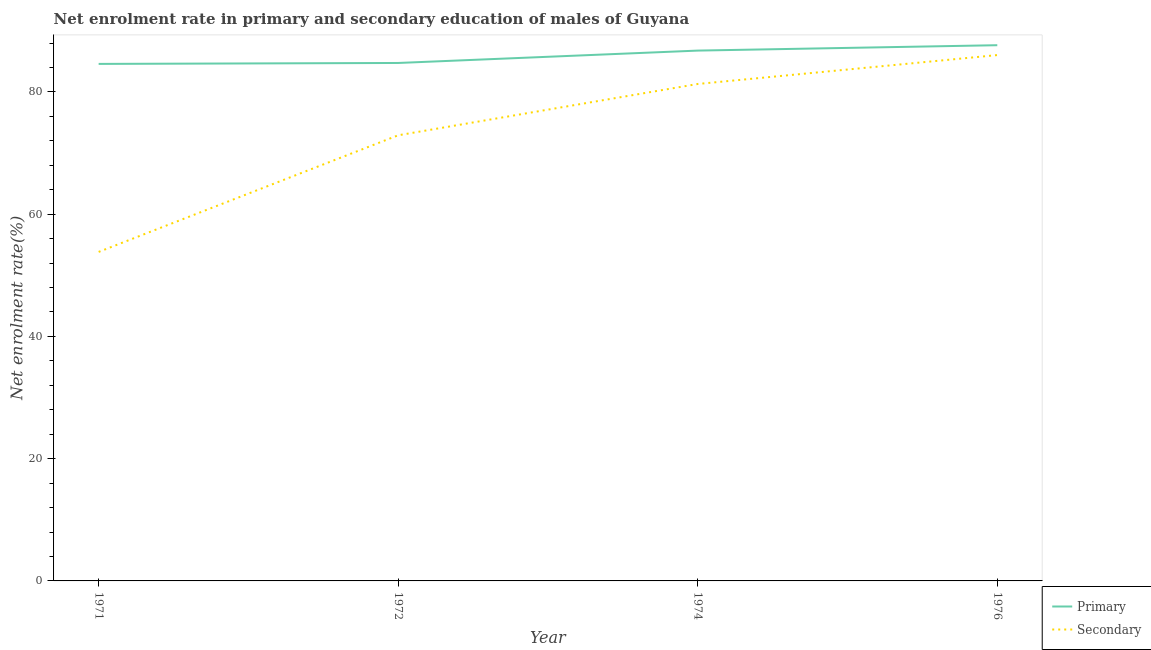How many different coloured lines are there?
Provide a succinct answer. 2. Does the line corresponding to enrollment rate in secondary education intersect with the line corresponding to enrollment rate in primary education?
Keep it short and to the point. No. What is the enrollment rate in primary education in 1971?
Your answer should be compact. 84.59. Across all years, what is the maximum enrollment rate in primary education?
Provide a short and direct response. 87.65. Across all years, what is the minimum enrollment rate in primary education?
Keep it short and to the point. 84.59. In which year was the enrollment rate in secondary education maximum?
Your response must be concise. 1976. What is the total enrollment rate in secondary education in the graph?
Your response must be concise. 294.07. What is the difference between the enrollment rate in secondary education in 1972 and that in 1974?
Offer a terse response. -8.39. What is the difference between the enrollment rate in secondary education in 1974 and the enrollment rate in primary education in 1971?
Your response must be concise. -3.28. What is the average enrollment rate in primary education per year?
Your answer should be compact. 85.93. In the year 1976, what is the difference between the enrollment rate in primary education and enrollment rate in secondary education?
Provide a short and direct response. 1.61. In how many years, is the enrollment rate in secondary education greater than 28 %?
Offer a very short reply. 4. What is the ratio of the enrollment rate in primary education in 1971 to that in 1976?
Provide a short and direct response. 0.97. What is the difference between the highest and the second highest enrollment rate in primary education?
Offer a terse response. 0.88. What is the difference between the highest and the lowest enrollment rate in secondary education?
Offer a very short reply. 32.21. In how many years, is the enrollment rate in primary education greater than the average enrollment rate in primary education taken over all years?
Offer a terse response. 2. Is the sum of the enrollment rate in primary education in 1971 and 1974 greater than the maximum enrollment rate in secondary education across all years?
Make the answer very short. Yes. Does the enrollment rate in primary education monotonically increase over the years?
Make the answer very short. Yes. Is the enrollment rate in secondary education strictly less than the enrollment rate in primary education over the years?
Ensure brevity in your answer.  Yes. How many lines are there?
Give a very brief answer. 2. How many years are there in the graph?
Offer a very short reply. 4. What is the difference between two consecutive major ticks on the Y-axis?
Ensure brevity in your answer.  20. Where does the legend appear in the graph?
Make the answer very short. Bottom right. What is the title of the graph?
Offer a very short reply. Net enrolment rate in primary and secondary education of males of Guyana. What is the label or title of the Y-axis?
Ensure brevity in your answer.  Net enrolment rate(%). What is the Net enrolment rate(%) of Primary in 1971?
Your response must be concise. 84.59. What is the Net enrolment rate(%) of Secondary in 1971?
Provide a succinct answer. 53.83. What is the Net enrolment rate(%) of Primary in 1972?
Provide a short and direct response. 84.74. What is the Net enrolment rate(%) of Secondary in 1972?
Your answer should be very brief. 72.91. What is the Net enrolment rate(%) of Primary in 1974?
Your answer should be compact. 86.76. What is the Net enrolment rate(%) of Secondary in 1974?
Your answer should be compact. 81.3. What is the Net enrolment rate(%) in Primary in 1976?
Provide a succinct answer. 87.65. What is the Net enrolment rate(%) in Secondary in 1976?
Your answer should be compact. 86.03. Across all years, what is the maximum Net enrolment rate(%) in Primary?
Keep it short and to the point. 87.65. Across all years, what is the maximum Net enrolment rate(%) in Secondary?
Make the answer very short. 86.03. Across all years, what is the minimum Net enrolment rate(%) of Primary?
Your response must be concise. 84.59. Across all years, what is the minimum Net enrolment rate(%) in Secondary?
Offer a very short reply. 53.83. What is the total Net enrolment rate(%) of Primary in the graph?
Your answer should be very brief. 343.74. What is the total Net enrolment rate(%) of Secondary in the graph?
Provide a short and direct response. 294.07. What is the difference between the Net enrolment rate(%) of Primary in 1971 and that in 1972?
Your response must be concise. -0.15. What is the difference between the Net enrolment rate(%) in Secondary in 1971 and that in 1972?
Keep it short and to the point. -19.08. What is the difference between the Net enrolment rate(%) in Primary in 1971 and that in 1974?
Your answer should be very brief. -2.18. What is the difference between the Net enrolment rate(%) in Secondary in 1971 and that in 1974?
Make the answer very short. -27.47. What is the difference between the Net enrolment rate(%) of Primary in 1971 and that in 1976?
Your answer should be very brief. -3.06. What is the difference between the Net enrolment rate(%) in Secondary in 1971 and that in 1976?
Your answer should be very brief. -32.21. What is the difference between the Net enrolment rate(%) of Primary in 1972 and that in 1974?
Your response must be concise. -2.02. What is the difference between the Net enrolment rate(%) in Secondary in 1972 and that in 1974?
Keep it short and to the point. -8.39. What is the difference between the Net enrolment rate(%) in Primary in 1972 and that in 1976?
Provide a succinct answer. -2.91. What is the difference between the Net enrolment rate(%) in Secondary in 1972 and that in 1976?
Give a very brief answer. -13.12. What is the difference between the Net enrolment rate(%) in Primary in 1974 and that in 1976?
Your answer should be very brief. -0.88. What is the difference between the Net enrolment rate(%) of Secondary in 1974 and that in 1976?
Your response must be concise. -4.73. What is the difference between the Net enrolment rate(%) in Primary in 1971 and the Net enrolment rate(%) in Secondary in 1972?
Offer a very short reply. 11.68. What is the difference between the Net enrolment rate(%) of Primary in 1971 and the Net enrolment rate(%) of Secondary in 1974?
Keep it short and to the point. 3.28. What is the difference between the Net enrolment rate(%) in Primary in 1971 and the Net enrolment rate(%) in Secondary in 1976?
Offer a very short reply. -1.45. What is the difference between the Net enrolment rate(%) in Primary in 1972 and the Net enrolment rate(%) in Secondary in 1974?
Give a very brief answer. 3.44. What is the difference between the Net enrolment rate(%) of Primary in 1972 and the Net enrolment rate(%) of Secondary in 1976?
Provide a short and direct response. -1.29. What is the difference between the Net enrolment rate(%) in Primary in 1974 and the Net enrolment rate(%) in Secondary in 1976?
Provide a short and direct response. 0.73. What is the average Net enrolment rate(%) of Primary per year?
Your answer should be compact. 85.93. What is the average Net enrolment rate(%) in Secondary per year?
Your answer should be compact. 73.52. In the year 1971, what is the difference between the Net enrolment rate(%) of Primary and Net enrolment rate(%) of Secondary?
Your answer should be compact. 30.76. In the year 1972, what is the difference between the Net enrolment rate(%) of Primary and Net enrolment rate(%) of Secondary?
Your response must be concise. 11.83. In the year 1974, what is the difference between the Net enrolment rate(%) of Primary and Net enrolment rate(%) of Secondary?
Provide a succinct answer. 5.46. In the year 1976, what is the difference between the Net enrolment rate(%) of Primary and Net enrolment rate(%) of Secondary?
Offer a terse response. 1.61. What is the ratio of the Net enrolment rate(%) of Secondary in 1971 to that in 1972?
Provide a short and direct response. 0.74. What is the ratio of the Net enrolment rate(%) of Primary in 1971 to that in 1974?
Offer a very short reply. 0.97. What is the ratio of the Net enrolment rate(%) in Secondary in 1971 to that in 1974?
Offer a terse response. 0.66. What is the ratio of the Net enrolment rate(%) of Primary in 1971 to that in 1976?
Offer a very short reply. 0.97. What is the ratio of the Net enrolment rate(%) in Secondary in 1971 to that in 1976?
Ensure brevity in your answer.  0.63. What is the ratio of the Net enrolment rate(%) of Primary in 1972 to that in 1974?
Offer a very short reply. 0.98. What is the ratio of the Net enrolment rate(%) in Secondary in 1972 to that in 1974?
Offer a terse response. 0.9. What is the ratio of the Net enrolment rate(%) of Primary in 1972 to that in 1976?
Keep it short and to the point. 0.97. What is the ratio of the Net enrolment rate(%) of Secondary in 1972 to that in 1976?
Your answer should be very brief. 0.85. What is the ratio of the Net enrolment rate(%) of Secondary in 1974 to that in 1976?
Provide a short and direct response. 0.94. What is the difference between the highest and the second highest Net enrolment rate(%) of Primary?
Your answer should be compact. 0.88. What is the difference between the highest and the second highest Net enrolment rate(%) of Secondary?
Your response must be concise. 4.73. What is the difference between the highest and the lowest Net enrolment rate(%) in Primary?
Keep it short and to the point. 3.06. What is the difference between the highest and the lowest Net enrolment rate(%) of Secondary?
Offer a terse response. 32.21. 